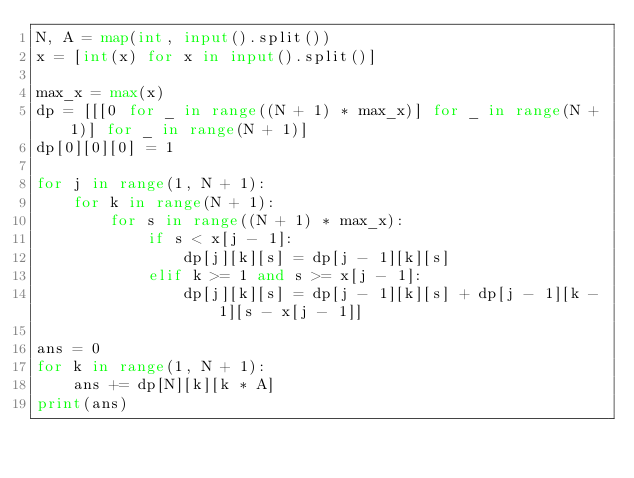Convert code to text. <code><loc_0><loc_0><loc_500><loc_500><_Python_>N, A = map(int, input().split())
x = [int(x) for x in input().split()]

max_x = max(x)
dp = [[[0 for _ in range((N + 1) * max_x)] for _ in range(N + 1)] for _ in range(N + 1)]
dp[0][0][0] = 1

for j in range(1, N + 1):
    for k in range(N + 1):
        for s in range((N + 1) * max_x):
            if s < x[j - 1]:
                dp[j][k][s] = dp[j - 1][k][s]
            elif k >= 1 and s >= x[j - 1]:
                dp[j][k][s] = dp[j - 1][k][s] + dp[j - 1][k - 1][s - x[j - 1]]

ans = 0
for k in range(1, N + 1):
    ans += dp[N][k][k * A]
print(ans)
</code> 